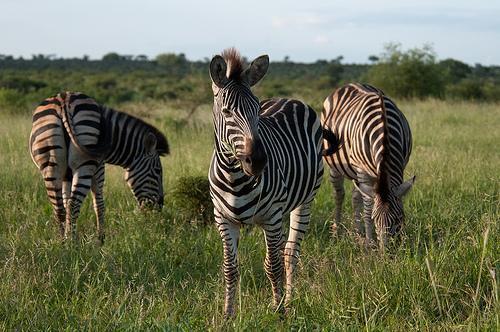How many zebras are there?
Give a very brief answer. 3. 